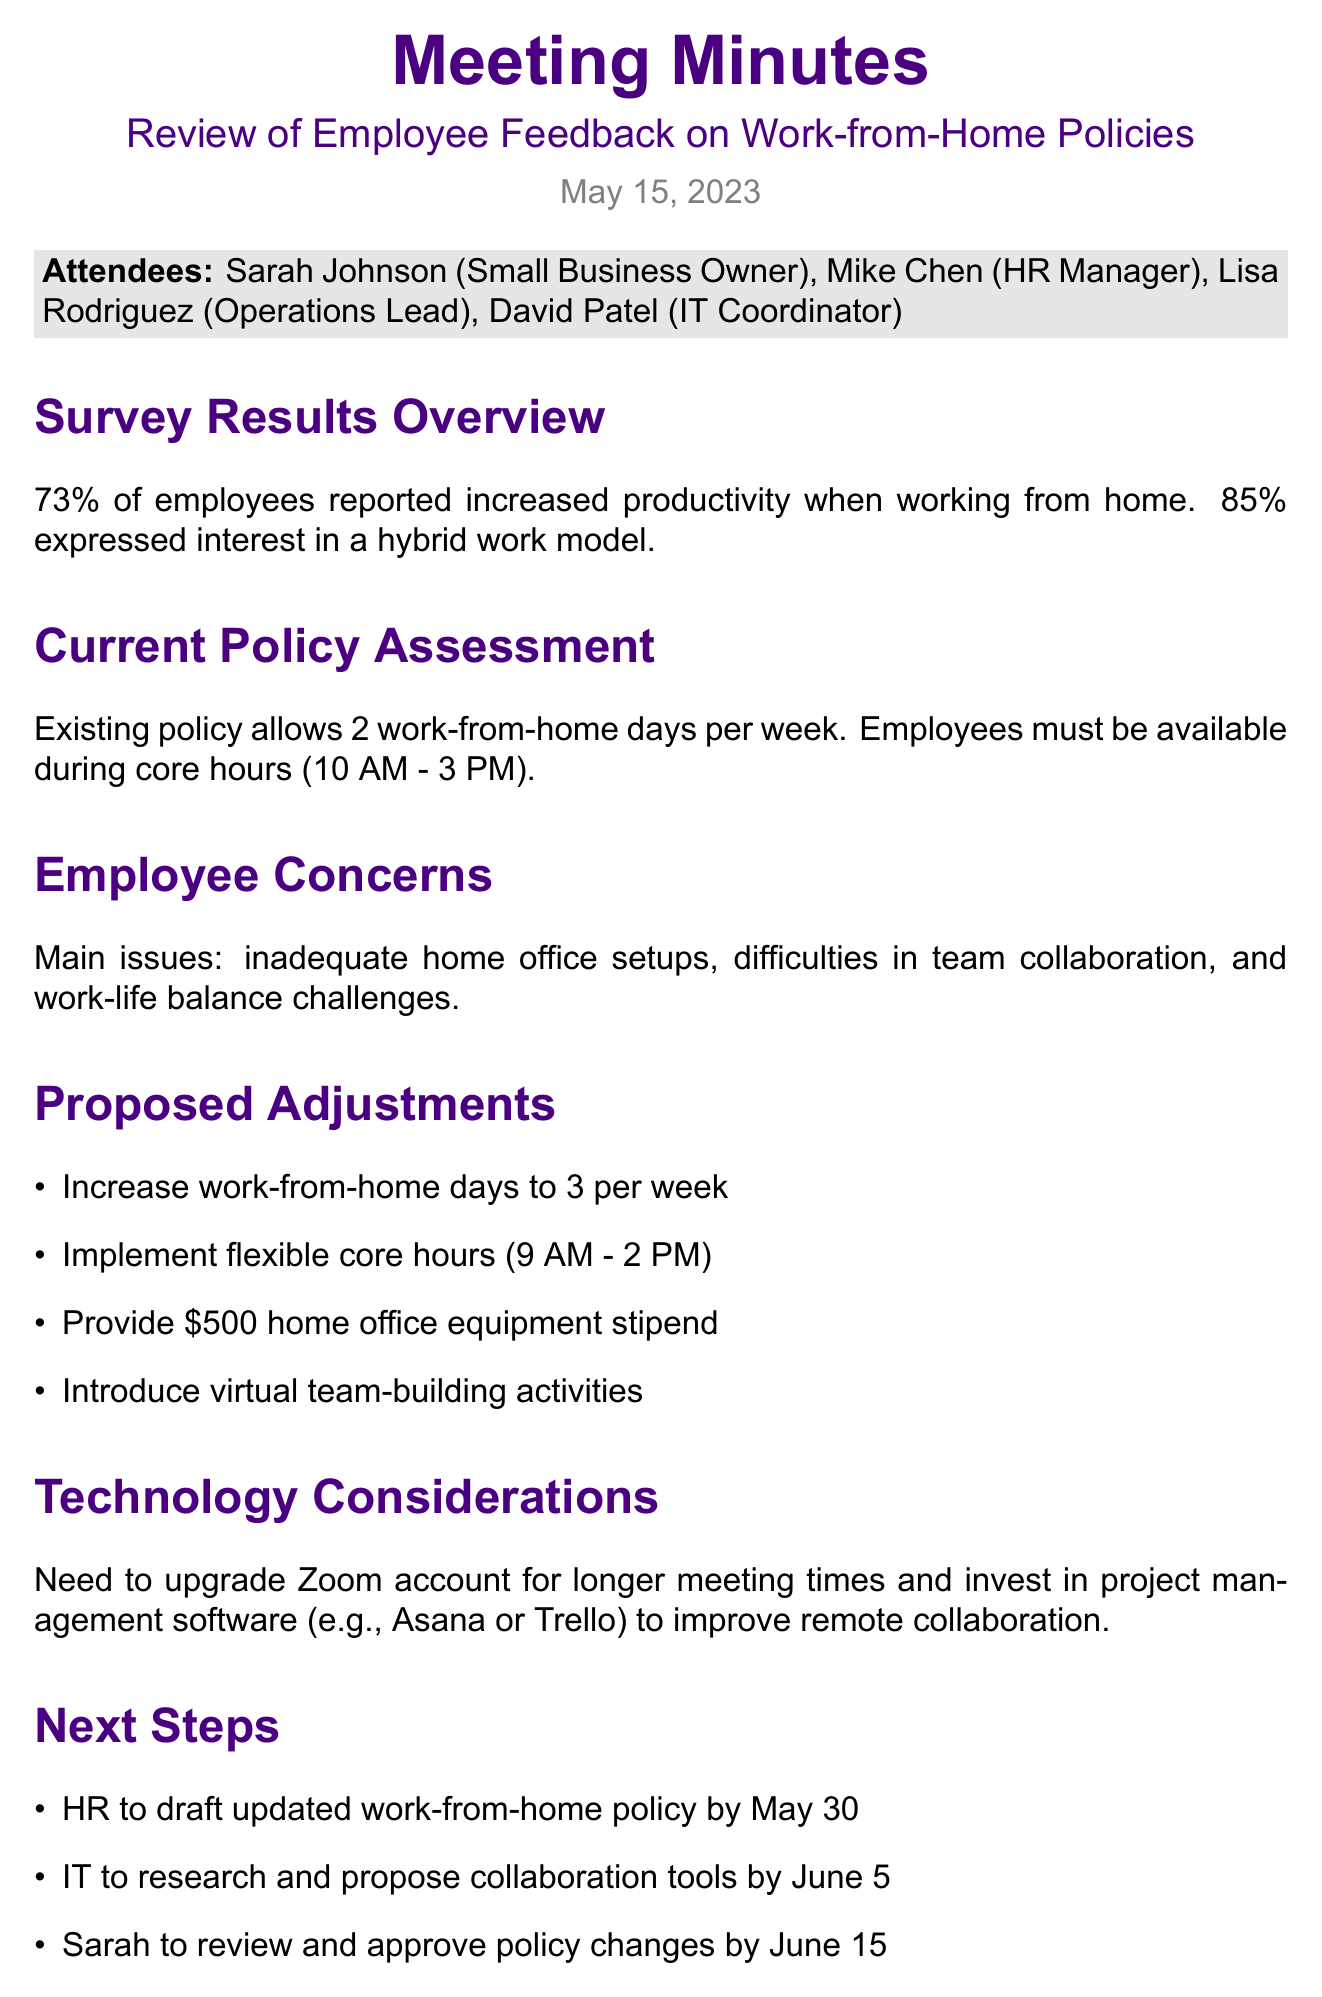What percentage of employees reported increased productivity when working from home? The document states that 73% of employees reported increased productivity when working from home.
Answer: 73% How many work-from-home days are currently allowed per week? The existing policy allows 2 work-from-home days per week.
Answer: 2 What was the main concern regarding team collaboration? The document lists difficulties in team collaboration as a main employee concern.
Answer: Difficulties in team collaboration What is the proposed amount for the home office equipment stipend? The proposed adjustment includes providing a $500 home office equipment stipend.
Answer: $500 What flexible core hours are being proposed? The proposed flexible core hours are from 9 AM to 2 PM.
Answer: 9 AM - 2 PM By when is HR expected to draft the updated work-from-home policy? According to the document, HR is to draft the updated work-from-home policy by May 30.
Answer: May 30 What percentage of employees expressed interest in a hybrid work model? The document states that 85% of employees expressed interest in a hybrid work model.
Answer: 85% Which project management software is mentioned for investment? The document mentions investing in Asana or Trello for improved remote collaboration.
Answer: Asana or Trello What is the date of the all-hands meeting to announce the new policy? The document indicates that the all-hands meeting will be held on June 20.
Answer: June 20 